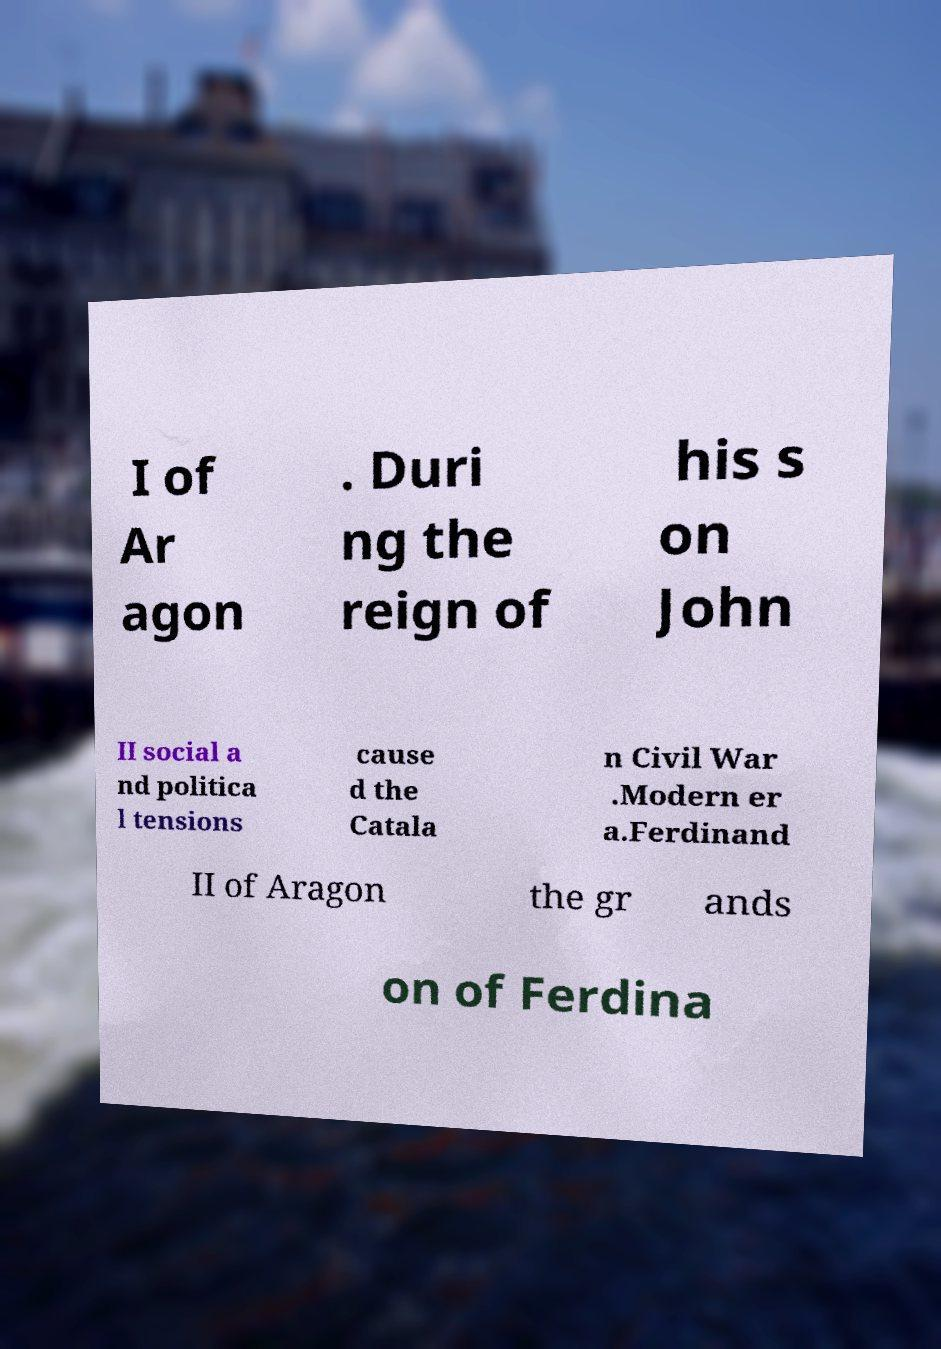Could you assist in decoding the text presented in this image and type it out clearly? I of Ar agon . Duri ng the reign of his s on John II social a nd politica l tensions cause d the Catala n Civil War .Modern er a.Ferdinand II of Aragon the gr ands on of Ferdina 